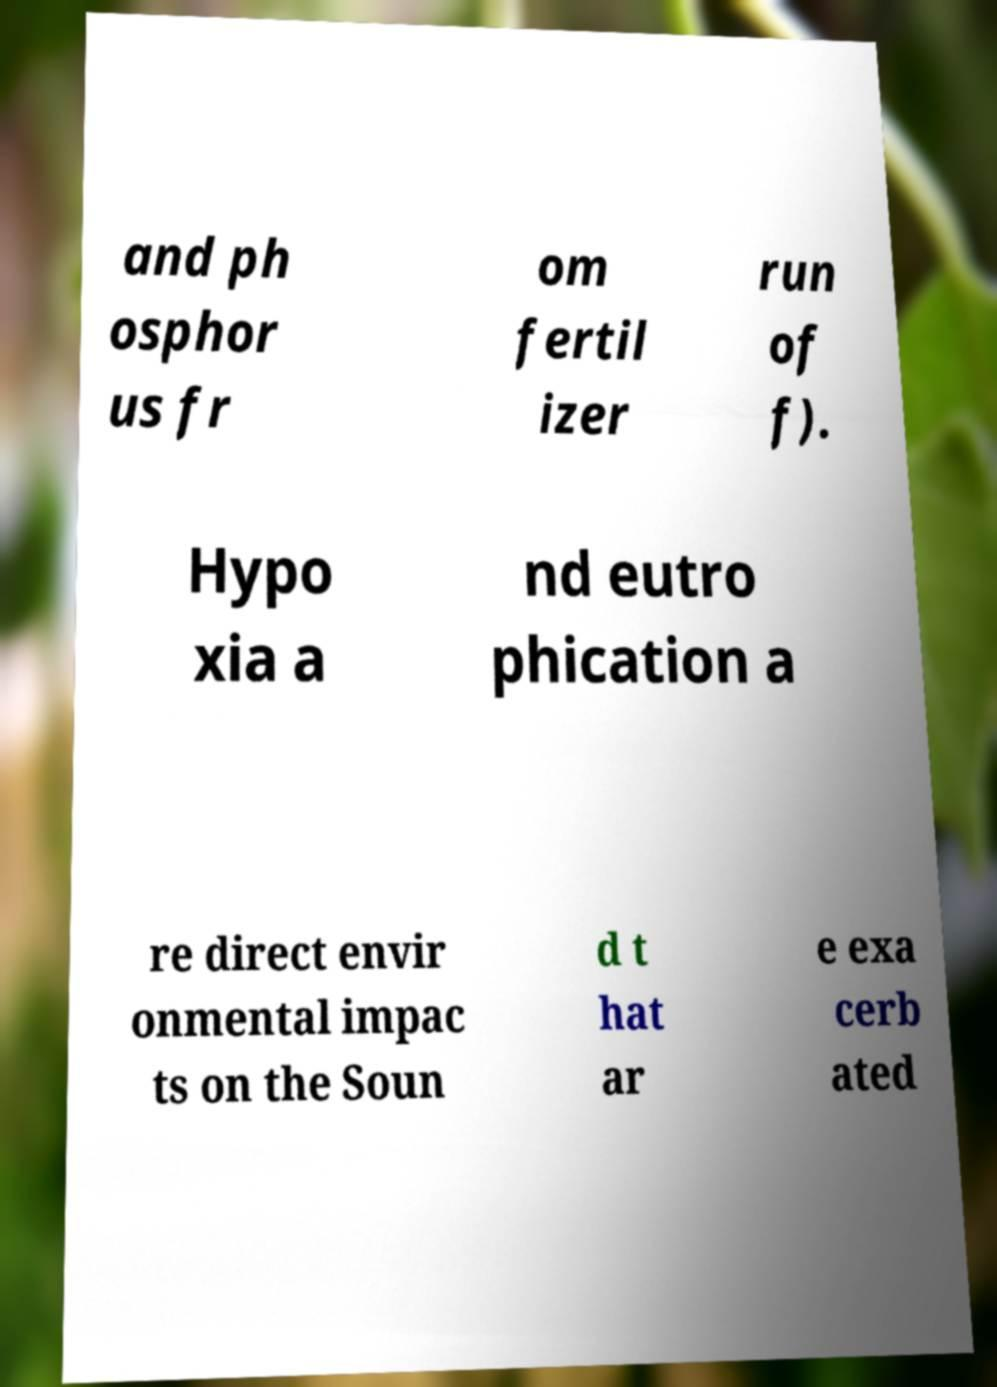Could you extract and type out the text from this image? and ph osphor us fr om fertil izer run of f). Hypo xia a nd eutro phication a re direct envir onmental impac ts on the Soun d t hat ar e exa cerb ated 